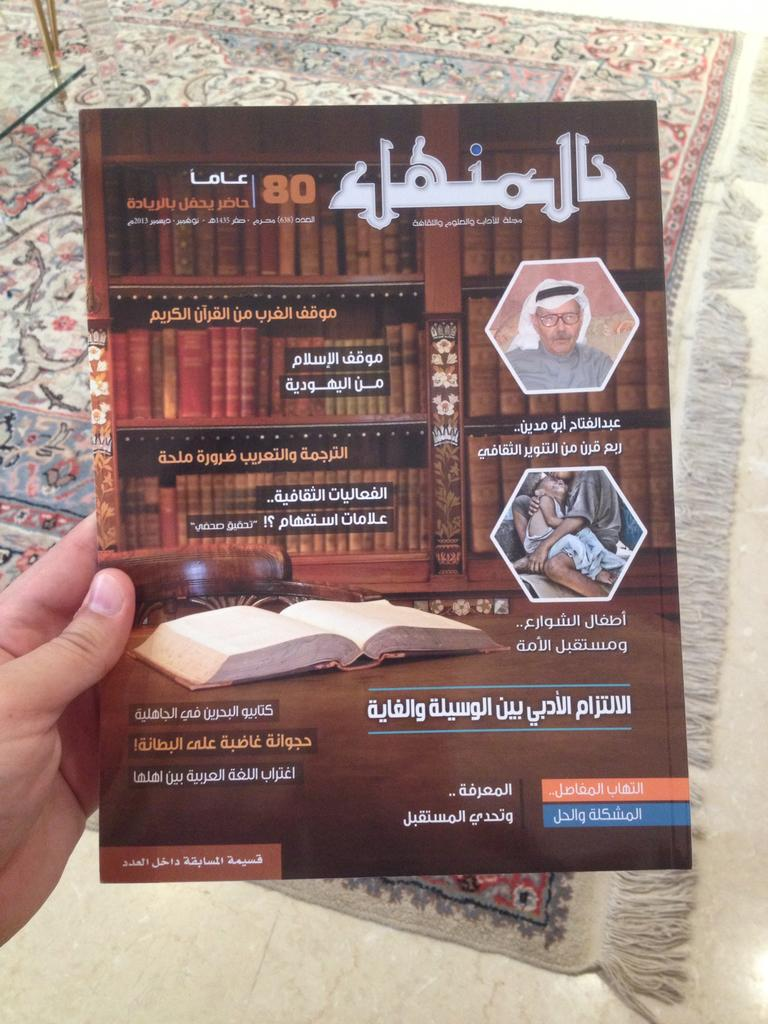What is the person in the image holding? The person is holding a book in the image. What can be found inside the book? The book contains text and an image. What is on the ground in the image? There is a cloth and an object on the ground in the image. How many ants can be seen crawling on the dust in the alley in the image? There is no alley, dust, or ants present in the image. 